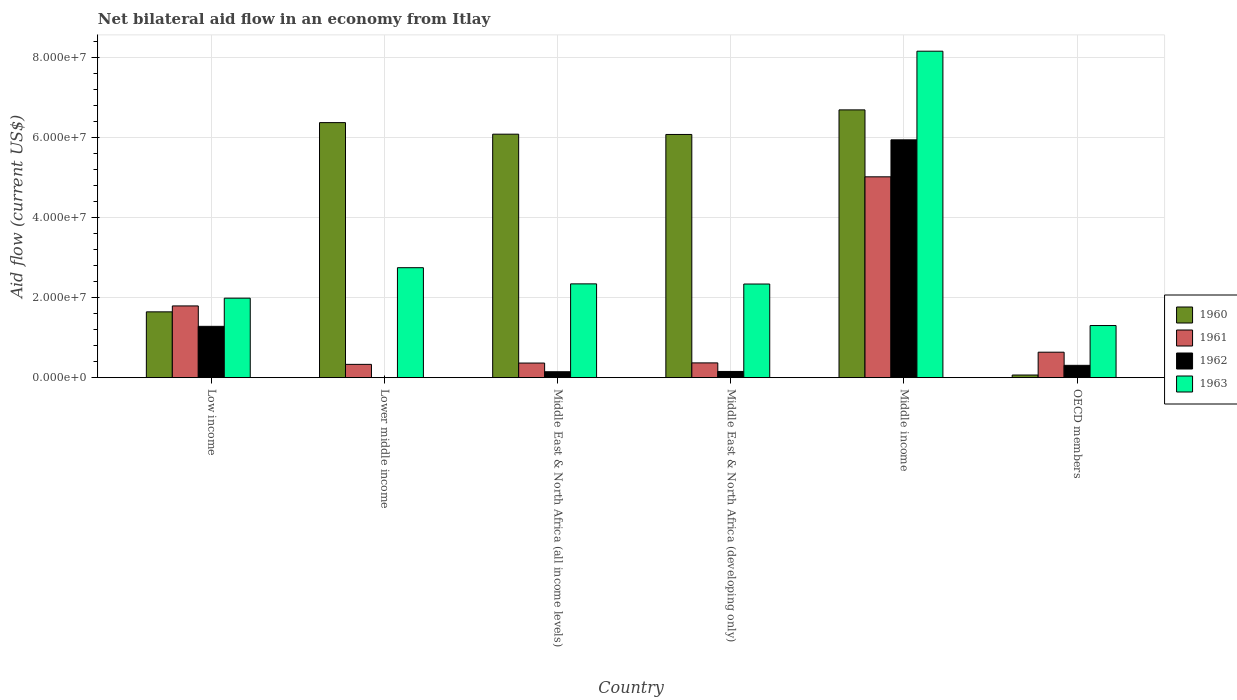How many bars are there on the 4th tick from the right?
Keep it short and to the point. 4. What is the label of the 3rd group of bars from the left?
Provide a short and direct response. Middle East & North Africa (all income levels). In how many cases, is the number of bars for a given country not equal to the number of legend labels?
Make the answer very short. 1. What is the net bilateral aid flow in 1960 in Middle East & North Africa (all income levels)?
Provide a succinct answer. 6.08e+07. Across all countries, what is the maximum net bilateral aid flow in 1960?
Ensure brevity in your answer.  6.69e+07. Across all countries, what is the minimum net bilateral aid flow in 1961?
Your answer should be very brief. 3.32e+06. In which country was the net bilateral aid flow in 1963 maximum?
Your answer should be compact. Middle income. What is the total net bilateral aid flow in 1963 in the graph?
Offer a terse response. 1.89e+08. What is the difference between the net bilateral aid flow in 1963 in Low income and that in Middle East & North Africa (developing only)?
Ensure brevity in your answer.  -3.53e+06. What is the difference between the net bilateral aid flow in 1963 in Middle East & North Africa (developing only) and the net bilateral aid flow in 1960 in OECD members?
Offer a terse response. 2.27e+07. What is the average net bilateral aid flow in 1963 per country?
Provide a succinct answer. 3.15e+07. What is the difference between the net bilateral aid flow of/in 1960 and net bilateral aid flow of/in 1963 in Low income?
Your answer should be very brief. -3.42e+06. In how many countries, is the net bilateral aid flow in 1960 greater than 40000000 US$?
Your response must be concise. 4. What is the ratio of the net bilateral aid flow in 1961 in Low income to that in Lower middle income?
Keep it short and to the point. 5.4. Is the net bilateral aid flow in 1961 in Middle East & North Africa (all income levels) less than that in OECD members?
Your response must be concise. Yes. Is the difference between the net bilateral aid flow in 1960 in Middle East & North Africa (all income levels) and Middle East & North Africa (developing only) greater than the difference between the net bilateral aid flow in 1963 in Middle East & North Africa (all income levels) and Middle East & North Africa (developing only)?
Provide a succinct answer. Yes. What is the difference between the highest and the second highest net bilateral aid flow in 1961?
Offer a terse response. 3.22e+07. What is the difference between the highest and the lowest net bilateral aid flow in 1960?
Your answer should be compact. 6.62e+07. Is the sum of the net bilateral aid flow in 1961 in Middle East & North Africa (all income levels) and Middle income greater than the maximum net bilateral aid flow in 1962 across all countries?
Your response must be concise. No. How many bars are there?
Offer a terse response. 23. How many countries are there in the graph?
Offer a terse response. 6. Are the values on the major ticks of Y-axis written in scientific E-notation?
Offer a very short reply. Yes. Does the graph contain any zero values?
Offer a terse response. Yes. Where does the legend appear in the graph?
Your answer should be compact. Center right. What is the title of the graph?
Your answer should be very brief. Net bilateral aid flow in an economy from Itlay. Does "2013" appear as one of the legend labels in the graph?
Your answer should be compact. No. What is the Aid flow (current US$) of 1960 in Low income?
Make the answer very short. 1.64e+07. What is the Aid flow (current US$) in 1961 in Low income?
Give a very brief answer. 1.79e+07. What is the Aid flow (current US$) in 1962 in Low income?
Offer a terse response. 1.28e+07. What is the Aid flow (current US$) in 1963 in Low income?
Your response must be concise. 1.99e+07. What is the Aid flow (current US$) in 1960 in Lower middle income?
Provide a succinct answer. 6.37e+07. What is the Aid flow (current US$) of 1961 in Lower middle income?
Offer a terse response. 3.32e+06. What is the Aid flow (current US$) of 1962 in Lower middle income?
Your response must be concise. 0. What is the Aid flow (current US$) of 1963 in Lower middle income?
Your answer should be compact. 2.75e+07. What is the Aid flow (current US$) in 1960 in Middle East & North Africa (all income levels)?
Your answer should be compact. 6.08e+07. What is the Aid flow (current US$) of 1961 in Middle East & North Africa (all income levels)?
Make the answer very short. 3.65e+06. What is the Aid flow (current US$) of 1962 in Middle East & North Africa (all income levels)?
Give a very brief answer. 1.48e+06. What is the Aid flow (current US$) in 1963 in Middle East & North Africa (all income levels)?
Ensure brevity in your answer.  2.34e+07. What is the Aid flow (current US$) in 1960 in Middle East & North Africa (developing only)?
Provide a short and direct response. 6.08e+07. What is the Aid flow (current US$) in 1961 in Middle East & North Africa (developing only)?
Your answer should be compact. 3.69e+06. What is the Aid flow (current US$) of 1962 in Middle East & North Africa (developing only)?
Ensure brevity in your answer.  1.55e+06. What is the Aid flow (current US$) of 1963 in Middle East & North Africa (developing only)?
Your answer should be compact. 2.34e+07. What is the Aid flow (current US$) in 1960 in Middle income?
Ensure brevity in your answer.  6.69e+07. What is the Aid flow (current US$) of 1961 in Middle income?
Provide a succinct answer. 5.02e+07. What is the Aid flow (current US$) of 1962 in Middle income?
Your response must be concise. 5.94e+07. What is the Aid flow (current US$) in 1963 in Middle income?
Provide a succinct answer. 8.16e+07. What is the Aid flow (current US$) of 1960 in OECD members?
Make the answer very short. 6.60e+05. What is the Aid flow (current US$) of 1961 in OECD members?
Your response must be concise. 6.36e+06. What is the Aid flow (current US$) of 1962 in OECD members?
Offer a very short reply. 3.08e+06. What is the Aid flow (current US$) in 1963 in OECD members?
Ensure brevity in your answer.  1.30e+07. Across all countries, what is the maximum Aid flow (current US$) of 1960?
Offer a terse response. 6.69e+07. Across all countries, what is the maximum Aid flow (current US$) of 1961?
Make the answer very short. 5.02e+07. Across all countries, what is the maximum Aid flow (current US$) of 1962?
Provide a short and direct response. 5.94e+07. Across all countries, what is the maximum Aid flow (current US$) of 1963?
Offer a very short reply. 8.16e+07. Across all countries, what is the minimum Aid flow (current US$) in 1961?
Offer a terse response. 3.32e+06. Across all countries, what is the minimum Aid flow (current US$) of 1963?
Ensure brevity in your answer.  1.30e+07. What is the total Aid flow (current US$) of 1960 in the graph?
Your response must be concise. 2.69e+08. What is the total Aid flow (current US$) in 1961 in the graph?
Give a very brief answer. 8.51e+07. What is the total Aid flow (current US$) in 1962 in the graph?
Your answer should be compact. 7.83e+07. What is the total Aid flow (current US$) in 1963 in the graph?
Give a very brief answer. 1.89e+08. What is the difference between the Aid flow (current US$) of 1960 in Low income and that in Lower middle income?
Provide a succinct answer. -4.73e+07. What is the difference between the Aid flow (current US$) in 1961 in Low income and that in Lower middle income?
Keep it short and to the point. 1.46e+07. What is the difference between the Aid flow (current US$) of 1963 in Low income and that in Lower middle income?
Ensure brevity in your answer.  -7.61e+06. What is the difference between the Aid flow (current US$) of 1960 in Low income and that in Middle East & North Africa (all income levels)?
Offer a terse response. -4.44e+07. What is the difference between the Aid flow (current US$) of 1961 in Low income and that in Middle East & North Africa (all income levels)?
Make the answer very short. 1.43e+07. What is the difference between the Aid flow (current US$) of 1962 in Low income and that in Middle East & North Africa (all income levels)?
Your answer should be compact. 1.13e+07. What is the difference between the Aid flow (current US$) of 1963 in Low income and that in Middle East & North Africa (all income levels)?
Your response must be concise. -3.57e+06. What is the difference between the Aid flow (current US$) of 1960 in Low income and that in Middle East & North Africa (developing only)?
Your answer should be very brief. -4.43e+07. What is the difference between the Aid flow (current US$) in 1961 in Low income and that in Middle East & North Africa (developing only)?
Make the answer very short. 1.42e+07. What is the difference between the Aid flow (current US$) of 1962 in Low income and that in Middle East & North Africa (developing only)?
Offer a very short reply. 1.13e+07. What is the difference between the Aid flow (current US$) of 1963 in Low income and that in Middle East & North Africa (developing only)?
Your response must be concise. -3.53e+06. What is the difference between the Aid flow (current US$) in 1960 in Low income and that in Middle income?
Provide a short and direct response. -5.04e+07. What is the difference between the Aid flow (current US$) of 1961 in Low income and that in Middle income?
Your response must be concise. -3.22e+07. What is the difference between the Aid flow (current US$) in 1962 in Low income and that in Middle income?
Your response must be concise. -4.66e+07. What is the difference between the Aid flow (current US$) in 1963 in Low income and that in Middle income?
Keep it short and to the point. -6.17e+07. What is the difference between the Aid flow (current US$) in 1960 in Low income and that in OECD members?
Your answer should be very brief. 1.58e+07. What is the difference between the Aid flow (current US$) of 1961 in Low income and that in OECD members?
Provide a succinct answer. 1.16e+07. What is the difference between the Aid flow (current US$) in 1962 in Low income and that in OECD members?
Provide a short and direct response. 9.74e+06. What is the difference between the Aid flow (current US$) in 1963 in Low income and that in OECD members?
Make the answer very short. 6.84e+06. What is the difference between the Aid flow (current US$) of 1960 in Lower middle income and that in Middle East & North Africa (all income levels)?
Provide a succinct answer. 2.89e+06. What is the difference between the Aid flow (current US$) of 1961 in Lower middle income and that in Middle East & North Africa (all income levels)?
Offer a terse response. -3.30e+05. What is the difference between the Aid flow (current US$) in 1963 in Lower middle income and that in Middle East & North Africa (all income levels)?
Offer a terse response. 4.04e+06. What is the difference between the Aid flow (current US$) of 1960 in Lower middle income and that in Middle East & North Africa (developing only)?
Ensure brevity in your answer.  2.96e+06. What is the difference between the Aid flow (current US$) in 1961 in Lower middle income and that in Middle East & North Africa (developing only)?
Keep it short and to the point. -3.70e+05. What is the difference between the Aid flow (current US$) in 1963 in Lower middle income and that in Middle East & North Africa (developing only)?
Keep it short and to the point. 4.08e+06. What is the difference between the Aid flow (current US$) in 1960 in Lower middle income and that in Middle income?
Keep it short and to the point. -3.18e+06. What is the difference between the Aid flow (current US$) in 1961 in Lower middle income and that in Middle income?
Offer a terse response. -4.68e+07. What is the difference between the Aid flow (current US$) of 1963 in Lower middle income and that in Middle income?
Provide a short and direct response. -5.41e+07. What is the difference between the Aid flow (current US$) in 1960 in Lower middle income and that in OECD members?
Your answer should be compact. 6.30e+07. What is the difference between the Aid flow (current US$) of 1961 in Lower middle income and that in OECD members?
Keep it short and to the point. -3.04e+06. What is the difference between the Aid flow (current US$) of 1963 in Lower middle income and that in OECD members?
Offer a very short reply. 1.44e+07. What is the difference between the Aid flow (current US$) of 1961 in Middle East & North Africa (all income levels) and that in Middle East & North Africa (developing only)?
Provide a short and direct response. -4.00e+04. What is the difference between the Aid flow (current US$) in 1962 in Middle East & North Africa (all income levels) and that in Middle East & North Africa (developing only)?
Keep it short and to the point. -7.00e+04. What is the difference between the Aid flow (current US$) in 1960 in Middle East & North Africa (all income levels) and that in Middle income?
Offer a terse response. -6.07e+06. What is the difference between the Aid flow (current US$) in 1961 in Middle East & North Africa (all income levels) and that in Middle income?
Your response must be concise. -4.65e+07. What is the difference between the Aid flow (current US$) in 1962 in Middle East & North Africa (all income levels) and that in Middle income?
Make the answer very short. -5.79e+07. What is the difference between the Aid flow (current US$) in 1963 in Middle East & North Africa (all income levels) and that in Middle income?
Keep it short and to the point. -5.81e+07. What is the difference between the Aid flow (current US$) of 1960 in Middle East & North Africa (all income levels) and that in OECD members?
Make the answer very short. 6.02e+07. What is the difference between the Aid flow (current US$) of 1961 in Middle East & North Africa (all income levels) and that in OECD members?
Ensure brevity in your answer.  -2.71e+06. What is the difference between the Aid flow (current US$) of 1962 in Middle East & North Africa (all income levels) and that in OECD members?
Make the answer very short. -1.60e+06. What is the difference between the Aid flow (current US$) in 1963 in Middle East & North Africa (all income levels) and that in OECD members?
Your answer should be compact. 1.04e+07. What is the difference between the Aid flow (current US$) in 1960 in Middle East & North Africa (developing only) and that in Middle income?
Offer a very short reply. -6.14e+06. What is the difference between the Aid flow (current US$) in 1961 in Middle East & North Africa (developing only) and that in Middle income?
Offer a very short reply. -4.65e+07. What is the difference between the Aid flow (current US$) in 1962 in Middle East & North Africa (developing only) and that in Middle income?
Offer a very short reply. -5.79e+07. What is the difference between the Aid flow (current US$) of 1963 in Middle East & North Africa (developing only) and that in Middle income?
Offer a very short reply. -5.82e+07. What is the difference between the Aid flow (current US$) in 1960 in Middle East & North Africa (developing only) and that in OECD members?
Provide a succinct answer. 6.01e+07. What is the difference between the Aid flow (current US$) in 1961 in Middle East & North Africa (developing only) and that in OECD members?
Offer a terse response. -2.67e+06. What is the difference between the Aid flow (current US$) in 1962 in Middle East & North Africa (developing only) and that in OECD members?
Give a very brief answer. -1.53e+06. What is the difference between the Aid flow (current US$) in 1963 in Middle East & North Africa (developing only) and that in OECD members?
Ensure brevity in your answer.  1.04e+07. What is the difference between the Aid flow (current US$) of 1960 in Middle income and that in OECD members?
Provide a succinct answer. 6.62e+07. What is the difference between the Aid flow (current US$) of 1961 in Middle income and that in OECD members?
Provide a succinct answer. 4.38e+07. What is the difference between the Aid flow (current US$) in 1962 in Middle income and that in OECD members?
Your answer should be compact. 5.63e+07. What is the difference between the Aid flow (current US$) of 1963 in Middle income and that in OECD members?
Your answer should be very brief. 6.85e+07. What is the difference between the Aid flow (current US$) in 1960 in Low income and the Aid flow (current US$) in 1961 in Lower middle income?
Ensure brevity in your answer.  1.31e+07. What is the difference between the Aid flow (current US$) of 1960 in Low income and the Aid flow (current US$) of 1963 in Lower middle income?
Provide a short and direct response. -1.10e+07. What is the difference between the Aid flow (current US$) of 1961 in Low income and the Aid flow (current US$) of 1963 in Lower middle income?
Ensure brevity in your answer.  -9.55e+06. What is the difference between the Aid flow (current US$) of 1962 in Low income and the Aid flow (current US$) of 1963 in Lower middle income?
Keep it short and to the point. -1.46e+07. What is the difference between the Aid flow (current US$) in 1960 in Low income and the Aid flow (current US$) in 1961 in Middle East & North Africa (all income levels)?
Provide a succinct answer. 1.28e+07. What is the difference between the Aid flow (current US$) of 1960 in Low income and the Aid flow (current US$) of 1962 in Middle East & North Africa (all income levels)?
Keep it short and to the point. 1.50e+07. What is the difference between the Aid flow (current US$) in 1960 in Low income and the Aid flow (current US$) in 1963 in Middle East & North Africa (all income levels)?
Keep it short and to the point. -6.99e+06. What is the difference between the Aid flow (current US$) of 1961 in Low income and the Aid flow (current US$) of 1962 in Middle East & North Africa (all income levels)?
Your answer should be compact. 1.64e+07. What is the difference between the Aid flow (current US$) of 1961 in Low income and the Aid flow (current US$) of 1963 in Middle East & North Africa (all income levels)?
Offer a very short reply. -5.51e+06. What is the difference between the Aid flow (current US$) in 1962 in Low income and the Aid flow (current US$) in 1963 in Middle East & North Africa (all income levels)?
Your answer should be very brief. -1.06e+07. What is the difference between the Aid flow (current US$) in 1960 in Low income and the Aid flow (current US$) in 1961 in Middle East & North Africa (developing only)?
Make the answer very short. 1.28e+07. What is the difference between the Aid flow (current US$) in 1960 in Low income and the Aid flow (current US$) in 1962 in Middle East & North Africa (developing only)?
Provide a short and direct response. 1.49e+07. What is the difference between the Aid flow (current US$) in 1960 in Low income and the Aid flow (current US$) in 1963 in Middle East & North Africa (developing only)?
Keep it short and to the point. -6.95e+06. What is the difference between the Aid flow (current US$) in 1961 in Low income and the Aid flow (current US$) in 1962 in Middle East & North Africa (developing only)?
Provide a short and direct response. 1.64e+07. What is the difference between the Aid flow (current US$) of 1961 in Low income and the Aid flow (current US$) of 1963 in Middle East & North Africa (developing only)?
Your answer should be very brief. -5.47e+06. What is the difference between the Aid flow (current US$) in 1962 in Low income and the Aid flow (current US$) in 1963 in Middle East & North Africa (developing only)?
Your answer should be compact. -1.06e+07. What is the difference between the Aid flow (current US$) in 1960 in Low income and the Aid flow (current US$) in 1961 in Middle income?
Give a very brief answer. -3.37e+07. What is the difference between the Aid flow (current US$) in 1960 in Low income and the Aid flow (current US$) in 1962 in Middle income?
Keep it short and to the point. -4.30e+07. What is the difference between the Aid flow (current US$) of 1960 in Low income and the Aid flow (current US$) of 1963 in Middle income?
Your answer should be very brief. -6.51e+07. What is the difference between the Aid flow (current US$) of 1961 in Low income and the Aid flow (current US$) of 1962 in Middle income?
Give a very brief answer. -4.15e+07. What is the difference between the Aid flow (current US$) in 1961 in Low income and the Aid flow (current US$) in 1963 in Middle income?
Your response must be concise. -6.36e+07. What is the difference between the Aid flow (current US$) of 1962 in Low income and the Aid flow (current US$) of 1963 in Middle income?
Offer a terse response. -6.87e+07. What is the difference between the Aid flow (current US$) of 1960 in Low income and the Aid flow (current US$) of 1961 in OECD members?
Your response must be concise. 1.01e+07. What is the difference between the Aid flow (current US$) in 1960 in Low income and the Aid flow (current US$) in 1962 in OECD members?
Give a very brief answer. 1.34e+07. What is the difference between the Aid flow (current US$) in 1960 in Low income and the Aid flow (current US$) in 1963 in OECD members?
Keep it short and to the point. 3.42e+06. What is the difference between the Aid flow (current US$) in 1961 in Low income and the Aid flow (current US$) in 1962 in OECD members?
Provide a short and direct response. 1.48e+07. What is the difference between the Aid flow (current US$) of 1961 in Low income and the Aid flow (current US$) of 1963 in OECD members?
Your answer should be compact. 4.90e+06. What is the difference between the Aid flow (current US$) of 1960 in Lower middle income and the Aid flow (current US$) of 1961 in Middle East & North Africa (all income levels)?
Keep it short and to the point. 6.01e+07. What is the difference between the Aid flow (current US$) in 1960 in Lower middle income and the Aid flow (current US$) in 1962 in Middle East & North Africa (all income levels)?
Your answer should be compact. 6.22e+07. What is the difference between the Aid flow (current US$) in 1960 in Lower middle income and the Aid flow (current US$) in 1963 in Middle East & North Africa (all income levels)?
Offer a terse response. 4.03e+07. What is the difference between the Aid flow (current US$) in 1961 in Lower middle income and the Aid flow (current US$) in 1962 in Middle East & North Africa (all income levels)?
Provide a succinct answer. 1.84e+06. What is the difference between the Aid flow (current US$) in 1961 in Lower middle income and the Aid flow (current US$) in 1963 in Middle East & North Africa (all income levels)?
Your response must be concise. -2.01e+07. What is the difference between the Aid flow (current US$) of 1960 in Lower middle income and the Aid flow (current US$) of 1961 in Middle East & North Africa (developing only)?
Provide a short and direct response. 6.00e+07. What is the difference between the Aid flow (current US$) in 1960 in Lower middle income and the Aid flow (current US$) in 1962 in Middle East & North Africa (developing only)?
Give a very brief answer. 6.22e+07. What is the difference between the Aid flow (current US$) in 1960 in Lower middle income and the Aid flow (current US$) in 1963 in Middle East & North Africa (developing only)?
Make the answer very short. 4.03e+07. What is the difference between the Aid flow (current US$) in 1961 in Lower middle income and the Aid flow (current US$) in 1962 in Middle East & North Africa (developing only)?
Keep it short and to the point. 1.77e+06. What is the difference between the Aid flow (current US$) of 1961 in Lower middle income and the Aid flow (current US$) of 1963 in Middle East & North Africa (developing only)?
Keep it short and to the point. -2.01e+07. What is the difference between the Aid flow (current US$) of 1960 in Lower middle income and the Aid flow (current US$) of 1961 in Middle income?
Provide a succinct answer. 1.35e+07. What is the difference between the Aid flow (current US$) in 1960 in Lower middle income and the Aid flow (current US$) in 1962 in Middle income?
Provide a succinct answer. 4.30e+06. What is the difference between the Aid flow (current US$) of 1960 in Lower middle income and the Aid flow (current US$) of 1963 in Middle income?
Your answer should be very brief. -1.78e+07. What is the difference between the Aid flow (current US$) in 1961 in Lower middle income and the Aid flow (current US$) in 1962 in Middle income?
Offer a terse response. -5.61e+07. What is the difference between the Aid flow (current US$) of 1961 in Lower middle income and the Aid flow (current US$) of 1963 in Middle income?
Ensure brevity in your answer.  -7.82e+07. What is the difference between the Aid flow (current US$) of 1960 in Lower middle income and the Aid flow (current US$) of 1961 in OECD members?
Ensure brevity in your answer.  5.74e+07. What is the difference between the Aid flow (current US$) of 1960 in Lower middle income and the Aid flow (current US$) of 1962 in OECD members?
Keep it short and to the point. 6.06e+07. What is the difference between the Aid flow (current US$) in 1960 in Lower middle income and the Aid flow (current US$) in 1963 in OECD members?
Offer a very short reply. 5.07e+07. What is the difference between the Aid flow (current US$) of 1961 in Lower middle income and the Aid flow (current US$) of 1963 in OECD members?
Make the answer very short. -9.70e+06. What is the difference between the Aid flow (current US$) in 1960 in Middle East & North Africa (all income levels) and the Aid flow (current US$) in 1961 in Middle East & North Africa (developing only)?
Your response must be concise. 5.71e+07. What is the difference between the Aid flow (current US$) in 1960 in Middle East & North Africa (all income levels) and the Aid flow (current US$) in 1962 in Middle East & North Africa (developing only)?
Offer a very short reply. 5.93e+07. What is the difference between the Aid flow (current US$) of 1960 in Middle East & North Africa (all income levels) and the Aid flow (current US$) of 1963 in Middle East & North Africa (developing only)?
Provide a short and direct response. 3.74e+07. What is the difference between the Aid flow (current US$) in 1961 in Middle East & North Africa (all income levels) and the Aid flow (current US$) in 1962 in Middle East & North Africa (developing only)?
Your answer should be compact. 2.10e+06. What is the difference between the Aid flow (current US$) in 1961 in Middle East & North Africa (all income levels) and the Aid flow (current US$) in 1963 in Middle East & North Africa (developing only)?
Offer a terse response. -1.97e+07. What is the difference between the Aid flow (current US$) in 1962 in Middle East & North Africa (all income levels) and the Aid flow (current US$) in 1963 in Middle East & North Africa (developing only)?
Your answer should be compact. -2.19e+07. What is the difference between the Aid flow (current US$) in 1960 in Middle East & North Africa (all income levels) and the Aid flow (current US$) in 1961 in Middle income?
Offer a terse response. 1.06e+07. What is the difference between the Aid flow (current US$) of 1960 in Middle East & North Africa (all income levels) and the Aid flow (current US$) of 1962 in Middle income?
Keep it short and to the point. 1.41e+06. What is the difference between the Aid flow (current US$) of 1960 in Middle East & North Africa (all income levels) and the Aid flow (current US$) of 1963 in Middle income?
Provide a short and direct response. -2.07e+07. What is the difference between the Aid flow (current US$) in 1961 in Middle East & North Africa (all income levels) and the Aid flow (current US$) in 1962 in Middle income?
Keep it short and to the point. -5.58e+07. What is the difference between the Aid flow (current US$) of 1961 in Middle East & North Africa (all income levels) and the Aid flow (current US$) of 1963 in Middle income?
Your response must be concise. -7.79e+07. What is the difference between the Aid flow (current US$) of 1962 in Middle East & North Africa (all income levels) and the Aid flow (current US$) of 1963 in Middle income?
Keep it short and to the point. -8.01e+07. What is the difference between the Aid flow (current US$) in 1960 in Middle East & North Africa (all income levels) and the Aid flow (current US$) in 1961 in OECD members?
Offer a very short reply. 5.45e+07. What is the difference between the Aid flow (current US$) of 1960 in Middle East & North Africa (all income levels) and the Aid flow (current US$) of 1962 in OECD members?
Provide a short and direct response. 5.77e+07. What is the difference between the Aid flow (current US$) in 1960 in Middle East & North Africa (all income levels) and the Aid flow (current US$) in 1963 in OECD members?
Your response must be concise. 4.78e+07. What is the difference between the Aid flow (current US$) in 1961 in Middle East & North Africa (all income levels) and the Aid flow (current US$) in 1962 in OECD members?
Your response must be concise. 5.70e+05. What is the difference between the Aid flow (current US$) in 1961 in Middle East & North Africa (all income levels) and the Aid flow (current US$) in 1963 in OECD members?
Provide a succinct answer. -9.37e+06. What is the difference between the Aid flow (current US$) in 1962 in Middle East & North Africa (all income levels) and the Aid flow (current US$) in 1963 in OECD members?
Offer a terse response. -1.15e+07. What is the difference between the Aid flow (current US$) in 1960 in Middle East & North Africa (developing only) and the Aid flow (current US$) in 1961 in Middle income?
Provide a succinct answer. 1.06e+07. What is the difference between the Aid flow (current US$) in 1960 in Middle East & North Africa (developing only) and the Aid flow (current US$) in 1962 in Middle income?
Your answer should be compact. 1.34e+06. What is the difference between the Aid flow (current US$) of 1960 in Middle East & North Africa (developing only) and the Aid flow (current US$) of 1963 in Middle income?
Offer a terse response. -2.08e+07. What is the difference between the Aid flow (current US$) of 1961 in Middle East & North Africa (developing only) and the Aid flow (current US$) of 1962 in Middle income?
Ensure brevity in your answer.  -5.57e+07. What is the difference between the Aid flow (current US$) of 1961 in Middle East & North Africa (developing only) and the Aid flow (current US$) of 1963 in Middle income?
Keep it short and to the point. -7.79e+07. What is the difference between the Aid flow (current US$) in 1962 in Middle East & North Africa (developing only) and the Aid flow (current US$) in 1963 in Middle income?
Provide a short and direct response. -8.00e+07. What is the difference between the Aid flow (current US$) in 1960 in Middle East & North Africa (developing only) and the Aid flow (current US$) in 1961 in OECD members?
Your answer should be very brief. 5.44e+07. What is the difference between the Aid flow (current US$) in 1960 in Middle East & North Africa (developing only) and the Aid flow (current US$) in 1962 in OECD members?
Your response must be concise. 5.77e+07. What is the difference between the Aid flow (current US$) in 1960 in Middle East & North Africa (developing only) and the Aid flow (current US$) in 1963 in OECD members?
Your answer should be compact. 4.77e+07. What is the difference between the Aid flow (current US$) in 1961 in Middle East & North Africa (developing only) and the Aid flow (current US$) in 1963 in OECD members?
Give a very brief answer. -9.33e+06. What is the difference between the Aid flow (current US$) of 1962 in Middle East & North Africa (developing only) and the Aid flow (current US$) of 1963 in OECD members?
Ensure brevity in your answer.  -1.15e+07. What is the difference between the Aid flow (current US$) in 1960 in Middle income and the Aid flow (current US$) in 1961 in OECD members?
Your response must be concise. 6.05e+07. What is the difference between the Aid flow (current US$) in 1960 in Middle income and the Aid flow (current US$) in 1962 in OECD members?
Give a very brief answer. 6.38e+07. What is the difference between the Aid flow (current US$) in 1960 in Middle income and the Aid flow (current US$) in 1963 in OECD members?
Your answer should be very brief. 5.39e+07. What is the difference between the Aid flow (current US$) in 1961 in Middle income and the Aid flow (current US$) in 1962 in OECD members?
Make the answer very short. 4.71e+07. What is the difference between the Aid flow (current US$) of 1961 in Middle income and the Aid flow (current US$) of 1963 in OECD members?
Offer a very short reply. 3.72e+07. What is the difference between the Aid flow (current US$) of 1962 in Middle income and the Aid flow (current US$) of 1963 in OECD members?
Ensure brevity in your answer.  4.64e+07. What is the average Aid flow (current US$) in 1960 per country?
Offer a terse response. 4.49e+07. What is the average Aid flow (current US$) in 1961 per country?
Give a very brief answer. 1.42e+07. What is the average Aid flow (current US$) of 1962 per country?
Make the answer very short. 1.31e+07. What is the average Aid flow (current US$) of 1963 per country?
Offer a terse response. 3.15e+07. What is the difference between the Aid flow (current US$) in 1960 and Aid flow (current US$) in 1961 in Low income?
Give a very brief answer. -1.48e+06. What is the difference between the Aid flow (current US$) in 1960 and Aid flow (current US$) in 1962 in Low income?
Your answer should be very brief. 3.62e+06. What is the difference between the Aid flow (current US$) of 1960 and Aid flow (current US$) of 1963 in Low income?
Provide a succinct answer. -3.42e+06. What is the difference between the Aid flow (current US$) of 1961 and Aid flow (current US$) of 1962 in Low income?
Provide a succinct answer. 5.10e+06. What is the difference between the Aid flow (current US$) in 1961 and Aid flow (current US$) in 1963 in Low income?
Keep it short and to the point. -1.94e+06. What is the difference between the Aid flow (current US$) in 1962 and Aid flow (current US$) in 1963 in Low income?
Provide a succinct answer. -7.04e+06. What is the difference between the Aid flow (current US$) of 1960 and Aid flow (current US$) of 1961 in Lower middle income?
Make the answer very short. 6.04e+07. What is the difference between the Aid flow (current US$) of 1960 and Aid flow (current US$) of 1963 in Lower middle income?
Your answer should be compact. 3.62e+07. What is the difference between the Aid flow (current US$) in 1961 and Aid flow (current US$) in 1963 in Lower middle income?
Ensure brevity in your answer.  -2.42e+07. What is the difference between the Aid flow (current US$) of 1960 and Aid flow (current US$) of 1961 in Middle East & North Africa (all income levels)?
Your answer should be compact. 5.72e+07. What is the difference between the Aid flow (current US$) in 1960 and Aid flow (current US$) in 1962 in Middle East & North Africa (all income levels)?
Your response must be concise. 5.93e+07. What is the difference between the Aid flow (current US$) in 1960 and Aid flow (current US$) in 1963 in Middle East & North Africa (all income levels)?
Provide a succinct answer. 3.74e+07. What is the difference between the Aid flow (current US$) in 1961 and Aid flow (current US$) in 1962 in Middle East & North Africa (all income levels)?
Your answer should be very brief. 2.17e+06. What is the difference between the Aid flow (current US$) of 1961 and Aid flow (current US$) of 1963 in Middle East & North Africa (all income levels)?
Your answer should be very brief. -1.98e+07. What is the difference between the Aid flow (current US$) in 1962 and Aid flow (current US$) in 1963 in Middle East & North Africa (all income levels)?
Your response must be concise. -2.20e+07. What is the difference between the Aid flow (current US$) in 1960 and Aid flow (current US$) in 1961 in Middle East & North Africa (developing only)?
Your answer should be very brief. 5.71e+07. What is the difference between the Aid flow (current US$) in 1960 and Aid flow (current US$) in 1962 in Middle East & North Africa (developing only)?
Provide a short and direct response. 5.92e+07. What is the difference between the Aid flow (current US$) of 1960 and Aid flow (current US$) of 1963 in Middle East & North Africa (developing only)?
Offer a terse response. 3.74e+07. What is the difference between the Aid flow (current US$) in 1961 and Aid flow (current US$) in 1962 in Middle East & North Africa (developing only)?
Your answer should be compact. 2.14e+06. What is the difference between the Aid flow (current US$) of 1961 and Aid flow (current US$) of 1963 in Middle East & North Africa (developing only)?
Offer a very short reply. -1.97e+07. What is the difference between the Aid flow (current US$) of 1962 and Aid flow (current US$) of 1963 in Middle East & North Africa (developing only)?
Keep it short and to the point. -2.18e+07. What is the difference between the Aid flow (current US$) of 1960 and Aid flow (current US$) of 1961 in Middle income?
Give a very brief answer. 1.67e+07. What is the difference between the Aid flow (current US$) of 1960 and Aid flow (current US$) of 1962 in Middle income?
Your answer should be compact. 7.48e+06. What is the difference between the Aid flow (current US$) in 1960 and Aid flow (current US$) in 1963 in Middle income?
Ensure brevity in your answer.  -1.47e+07. What is the difference between the Aid flow (current US$) in 1961 and Aid flow (current US$) in 1962 in Middle income?
Your answer should be very brief. -9.24e+06. What is the difference between the Aid flow (current US$) of 1961 and Aid flow (current US$) of 1963 in Middle income?
Your answer should be compact. -3.14e+07. What is the difference between the Aid flow (current US$) in 1962 and Aid flow (current US$) in 1963 in Middle income?
Keep it short and to the point. -2.21e+07. What is the difference between the Aid flow (current US$) of 1960 and Aid flow (current US$) of 1961 in OECD members?
Offer a terse response. -5.70e+06. What is the difference between the Aid flow (current US$) of 1960 and Aid flow (current US$) of 1962 in OECD members?
Ensure brevity in your answer.  -2.42e+06. What is the difference between the Aid flow (current US$) in 1960 and Aid flow (current US$) in 1963 in OECD members?
Offer a terse response. -1.24e+07. What is the difference between the Aid flow (current US$) of 1961 and Aid flow (current US$) of 1962 in OECD members?
Provide a succinct answer. 3.28e+06. What is the difference between the Aid flow (current US$) in 1961 and Aid flow (current US$) in 1963 in OECD members?
Make the answer very short. -6.66e+06. What is the difference between the Aid flow (current US$) of 1962 and Aid flow (current US$) of 1963 in OECD members?
Ensure brevity in your answer.  -9.94e+06. What is the ratio of the Aid flow (current US$) in 1960 in Low income to that in Lower middle income?
Offer a very short reply. 0.26. What is the ratio of the Aid flow (current US$) of 1961 in Low income to that in Lower middle income?
Your response must be concise. 5.4. What is the ratio of the Aid flow (current US$) in 1963 in Low income to that in Lower middle income?
Your response must be concise. 0.72. What is the ratio of the Aid flow (current US$) in 1960 in Low income to that in Middle East & North Africa (all income levels)?
Give a very brief answer. 0.27. What is the ratio of the Aid flow (current US$) of 1961 in Low income to that in Middle East & North Africa (all income levels)?
Provide a short and direct response. 4.91. What is the ratio of the Aid flow (current US$) of 1962 in Low income to that in Middle East & North Africa (all income levels)?
Your response must be concise. 8.66. What is the ratio of the Aid flow (current US$) of 1963 in Low income to that in Middle East & North Africa (all income levels)?
Make the answer very short. 0.85. What is the ratio of the Aid flow (current US$) in 1960 in Low income to that in Middle East & North Africa (developing only)?
Your answer should be very brief. 0.27. What is the ratio of the Aid flow (current US$) in 1961 in Low income to that in Middle East & North Africa (developing only)?
Make the answer very short. 4.86. What is the ratio of the Aid flow (current US$) in 1962 in Low income to that in Middle East & North Africa (developing only)?
Provide a short and direct response. 8.27. What is the ratio of the Aid flow (current US$) in 1963 in Low income to that in Middle East & North Africa (developing only)?
Your answer should be compact. 0.85. What is the ratio of the Aid flow (current US$) in 1960 in Low income to that in Middle income?
Your answer should be very brief. 0.25. What is the ratio of the Aid flow (current US$) of 1961 in Low income to that in Middle income?
Your answer should be very brief. 0.36. What is the ratio of the Aid flow (current US$) in 1962 in Low income to that in Middle income?
Your answer should be very brief. 0.22. What is the ratio of the Aid flow (current US$) of 1963 in Low income to that in Middle income?
Keep it short and to the point. 0.24. What is the ratio of the Aid flow (current US$) in 1960 in Low income to that in OECD members?
Provide a short and direct response. 24.91. What is the ratio of the Aid flow (current US$) of 1961 in Low income to that in OECD members?
Your answer should be very brief. 2.82. What is the ratio of the Aid flow (current US$) in 1962 in Low income to that in OECD members?
Give a very brief answer. 4.16. What is the ratio of the Aid flow (current US$) of 1963 in Low income to that in OECD members?
Make the answer very short. 1.53. What is the ratio of the Aid flow (current US$) of 1960 in Lower middle income to that in Middle East & North Africa (all income levels)?
Provide a succinct answer. 1.05. What is the ratio of the Aid flow (current US$) of 1961 in Lower middle income to that in Middle East & North Africa (all income levels)?
Offer a very short reply. 0.91. What is the ratio of the Aid flow (current US$) of 1963 in Lower middle income to that in Middle East & North Africa (all income levels)?
Your response must be concise. 1.17. What is the ratio of the Aid flow (current US$) of 1960 in Lower middle income to that in Middle East & North Africa (developing only)?
Make the answer very short. 1.05. What is the ratio of the Aid flow (current US$) in 1961 in Lower middle income to that in Middle East & North Africa (developing only)?
Your answer should be compact. 0.9. What is the ratio of the Aid flow (current US$) in 1963 in Lower middle income to that in Middle East & North Africa (developing only)?
Provide a succinct answer. 1.17. What is the ratio of the Aid flow (current US$) of 1960 in Lower middle income to that in Middle income?
Make the answer very short. 0.95. What is the ratio of the Aid flow (current US$) of 1961 in Lower middle income to that in Middle income?
Give a very brief answer. 0.07. What is the ratio of the Aid flow (current US$) of 1963 in Lower middle income to that in Middle income?
Ensure brevity in your answer.  0.34. What is the ratio of the Aid flow (current US$) of 1960 in Lower middle income to that in OECD members?
Your answer should be very brief. 96.53. What is the ratio of the Aid flow (current US$) in 1961 in Lower middle income to that in OECD members?
Your answer should be compact. 0.52. What is the ratio of the Aid flow (current US$) of 1963 in Lower middle income to that in OECD members?
Provide a short and direct response. 2.11. What is the ratio of the Aid flow (current US$) of 1962 in Middle East & North Africa (all income levels) to that in Middle East & North Africa (developing only)?
Provide a short and direct response. 0.95. What is the ratio of the Aid flow (current US$) of 1963 in Middle East & North Africa (all income levels) to that in Middle East & North Africa (developing only)?
Make the answer very short. 1. What is the ratio of the Aid flow (current US$) in 1960 in Middle East & North Africa (all income levels) to that in Middle income?
Give a very brief answer. 0.91. What is the ratio of the Aid flow (current US$) of 1961 in Middle East & North Africa (all income levels) to that in Middle income?
Provide a short and direct response. 0.07. What is the ratio of the Aid flow (current US$) in 1962 in Middle East & North Africa (all income levels) to that in Middle income?
Your response must be concise. 0.02. What is the ratio of the Aid flow (current US$) in 1963 in Middle East & North Africa (all income levels) to that in Middle income?
Offer a terse response. 0.29. What is the ratio of the Aid flow (current US$) of 1960 in Middle East & North Africa (all income levels) to that in OECD members?
Your response must be concise. 92.15. What is the ratio of the Aid flow (current US$) of 1961 in Middle East & North Africa (all income levels) to that in OECD members?
Your response must be concise. 0.57. What is the ratio of the Aid flow (current US$) of 1962 in Middle East & North Africa (all income levels) to that in OECD members?
Make the answer very short. 0.48. What is the ratio of the Aid flow (current US$) in 1963 in Middle East & North Africa (all income levels) to that in OECD members?
Offer a very short reply. 1.8. What is the ratio of the Aid flow (current US$) in 1960 in Middle East & North Africa (developing only) to that in Middle income?
Make the answer very short. 0.91. What is the ratio of the Aid flow (current US$) in 1961 in Middle East & North Africa (developing only) to that in Middle income?
Give a very brief answer. 0.07. What is the ratio of the Aid flow (current US$) of 1962 in Middle East & North Africa (developing only) to that in Middle income?
Provide a short and direct response. 0.03. What is the ratio of the Aid flow (current US$) of 1963 in Middle East & North Africa (developing only) to that in Middle income?
Offer a terse response. 0.29. What is the ratio of the Aid flow (current US$) in 1960 in Middle East & North Africa (developing only) to that in OECD members?
Ensure brevity in your answer.  92.05. What is the ratio of the Aid flow (current US$) of 1961 in Middle East & North Africa (developing only) to that in OECD members?
Your response must be concise. 0.58. What is the ratio of the Aid flow (current US$) in 1962 in Middle East & North Africa (developing only) to that in OECD members?
Offer a terse response. 0.5. What is the ratio of the Aid flow (current US$) of 1963 in Middle East & North Africa (developing only) to that in OECD members?
Your answer should be very brief. 1.8. What is the ratio of the Aid flow (current US$) of 1960 in Middle income to that in OECD members?
Give a very brief answer. 101.35. What is the ratio of the Aid flow (current US$) of 1961 in Middle income to that in OECD members?
Offer a terse response. 7.89. What is the ratio of the Aid flow (current US$) of 1962 in Middle income to that in OECD members?
Ensure brevity in your answer.  19.29. What is the ratio of the Aid flow (current US$) in 1963 in Middle income to that in OECD members?
Make the answer very short. 6.26. What is the difference between the highest and the second highest Aid flow (current US$) of 1960?
Offer a very short reply. 3.18e+06. What is the difference between the highest and the second highest Aid flow (current US$) of 1961?
Keep it short and to the point. 3.22e+07. What is the difference between the highest and the second highest Aid flow (current US$) of 1962?
Give a very brief answer. 4.66e+07. What is the difference between the highest and the second highest Aid flow (current US$) in 1963?
Provide a succinct answer. 5.41e+07. What is the difference between the highest and the lowest Aid flow (current US$) of 1960?
Offer a terse response. 6.62e+07. What is the difference between the highest and the lowest Aid flow (current US$) of 1961?
Give a very brief answer. 4.68e+07. What is the difference between the highest and the lowest Aid flow (current US$) of 1962?
Provide a short and direct response. 5.94e+07. What is the difference between the highest and the lowest Aid flow (current US$) in 1963?
Offer a terse response. 6.85e+07. 